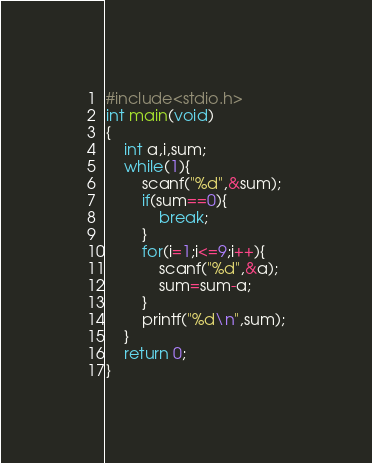<code> <loc_0><loc_0><loc_500><loc_500><_C_>#include<stdio.h>
int main(void)
{
	int a,i,sum;
	while(1){
		scanf("%d",&sum);
		if(sum==0){
			break;
		}
		for(i=1;i<=9;i++){
			scanf("%d",&a);
			sum=sum-a;
		}
		printf("%d\n",sum);
	}
	return 0;
}

</code> 